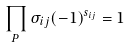Convert formula to latex. <formula><loc_0><loc_0><loc_500><loc_500>\prod _ { P } \sigma _ { i j } ( - 1 ) ^ { s _ { i j } } = 1</formula> 